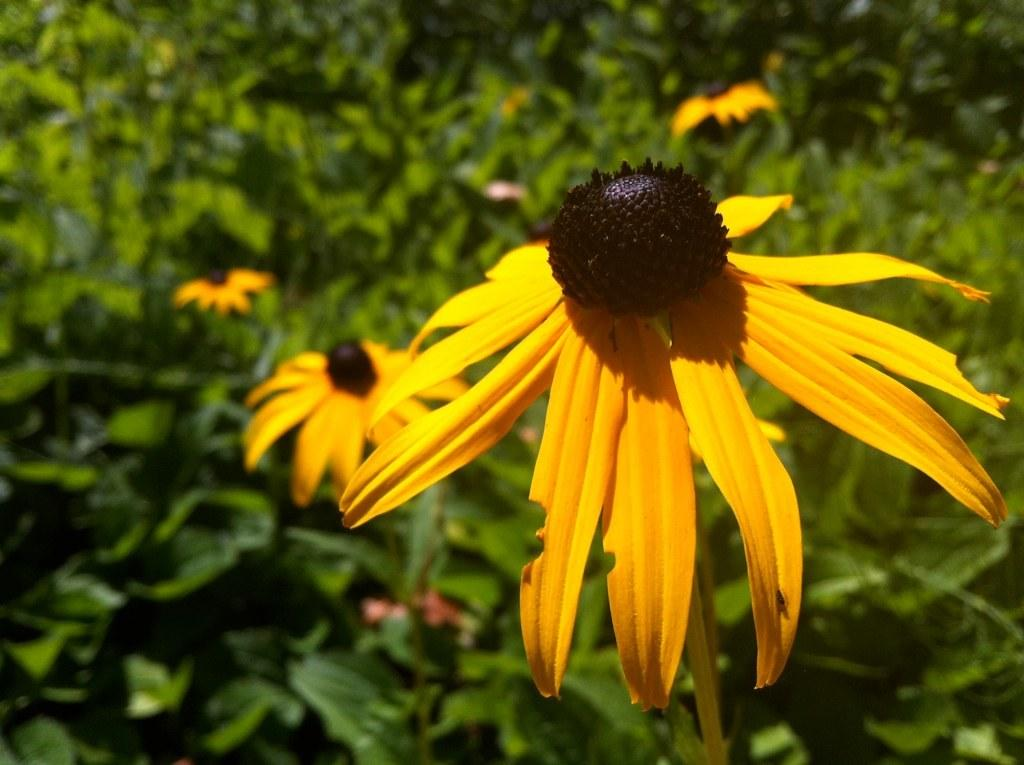What type of living organisms can be seen in the image? Plants can be seen in the image. What color are the flowers on the plants in the image? The flowers on the plants in the image are yellow. What color are the leaves of the plants in the background? The leaves of the plants in the background are green. Can you see any toes in the image? There are no toes visible in the image; it features plants with yellow flowers and green leaves in the background. 